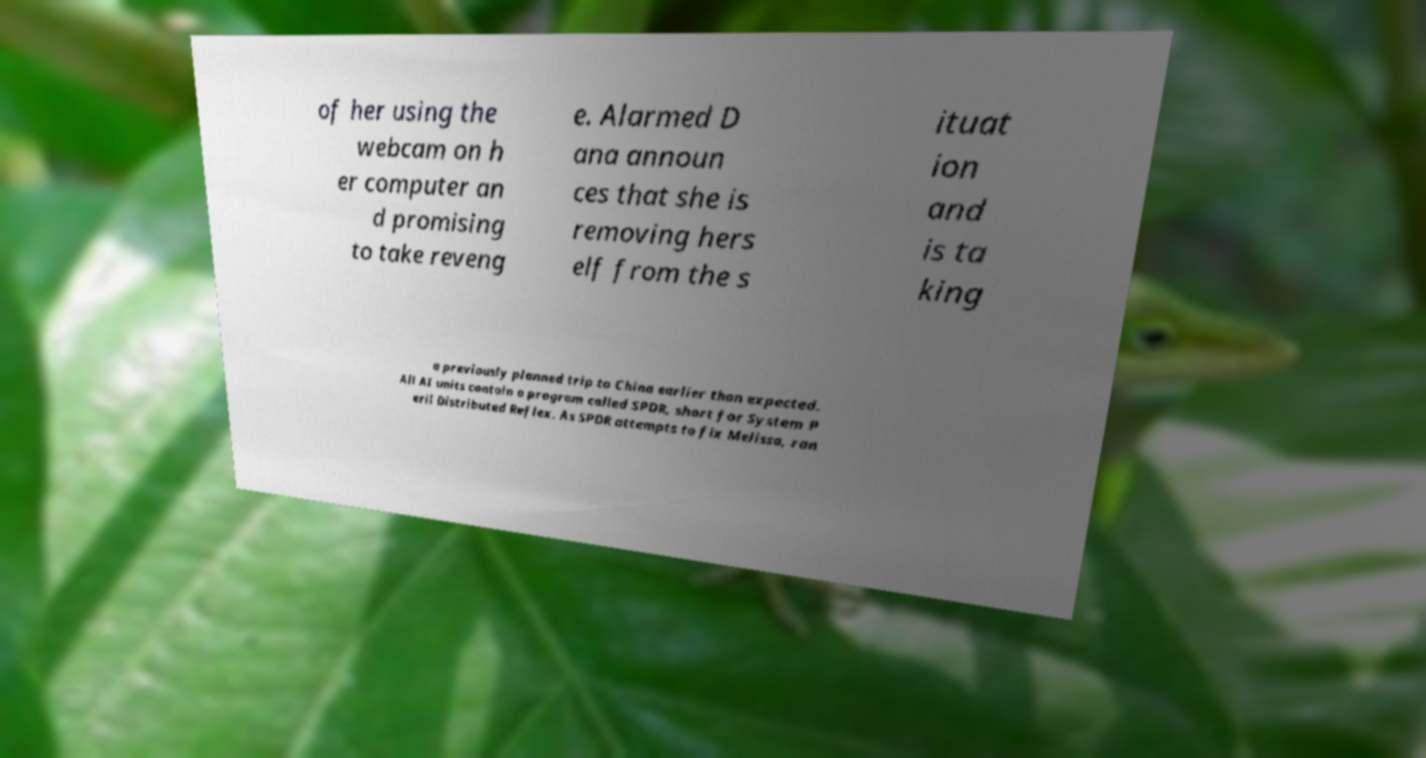Please read and relay the text visible in this image. What does it say? of her using the webcam on h er computer an d promising to take reveng e. Alarmed D ana announ ces that she is removing hers elf from the s ituat ion and is ta king a previously planned trip to China earlier than expected. All AI units contain a program called SPDR, short for System P eril Distributed Reflex. As SPDR attempts to fix Melissa, ran 